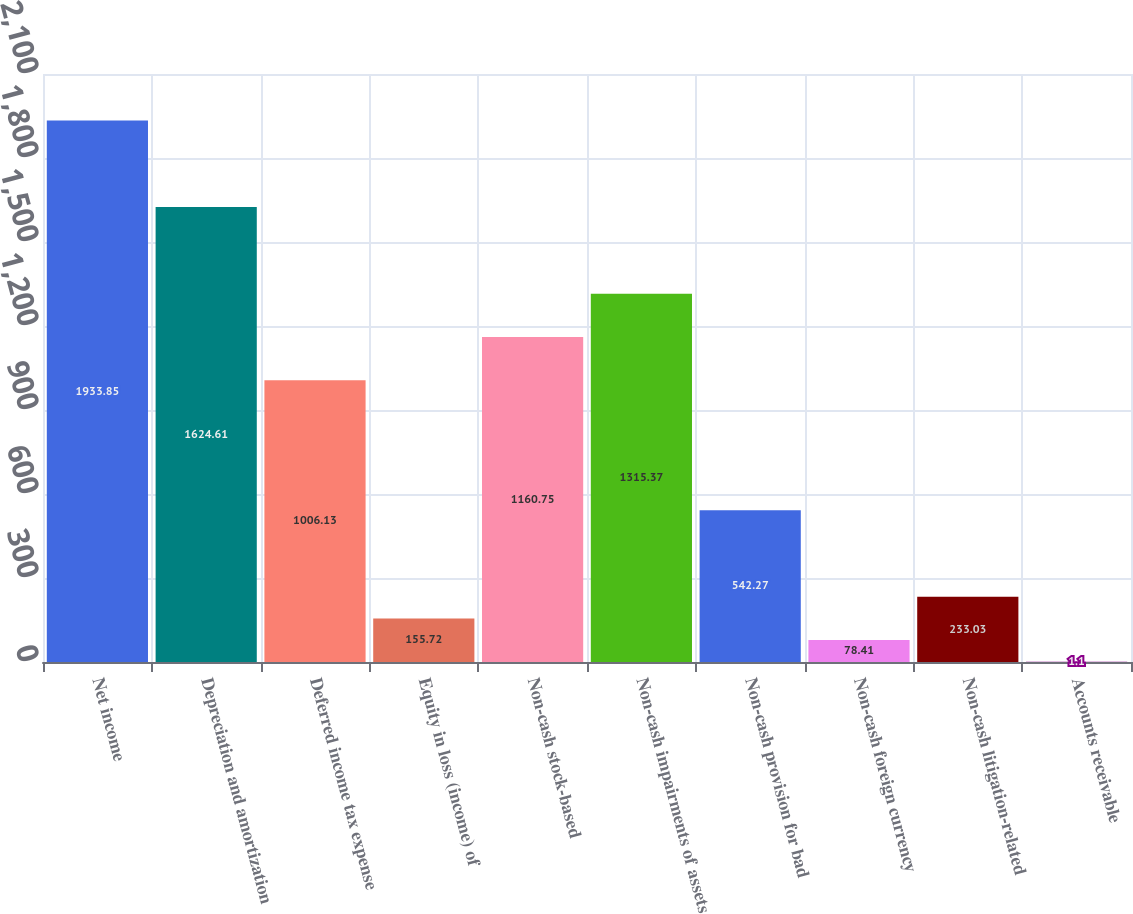<chart> <loc_0><loc_0><loc_500><loc_500><bar_chart><fcel>Net income<fcel>Depreciation and amortization<fcel>Deferred income tax expense<fcel>Equity in loss (income) of<fcel>Non-cash stock-based<fcel>Non-cash impairments of assets<fcel>Non-cash provision for bad<fcel>Non-cash foreign currency<fcel>Non-cash litigation-related<fcel>Accounts receivable<nl><fcel>1933.85<fcel>1624.61<fcel>1006.13<fcel>155.72<fcel>1160.75<fcel>1315.37<fcel>542.27<fcel>78.41<fcel>233.03<fcel>1.1<nl></chart> 